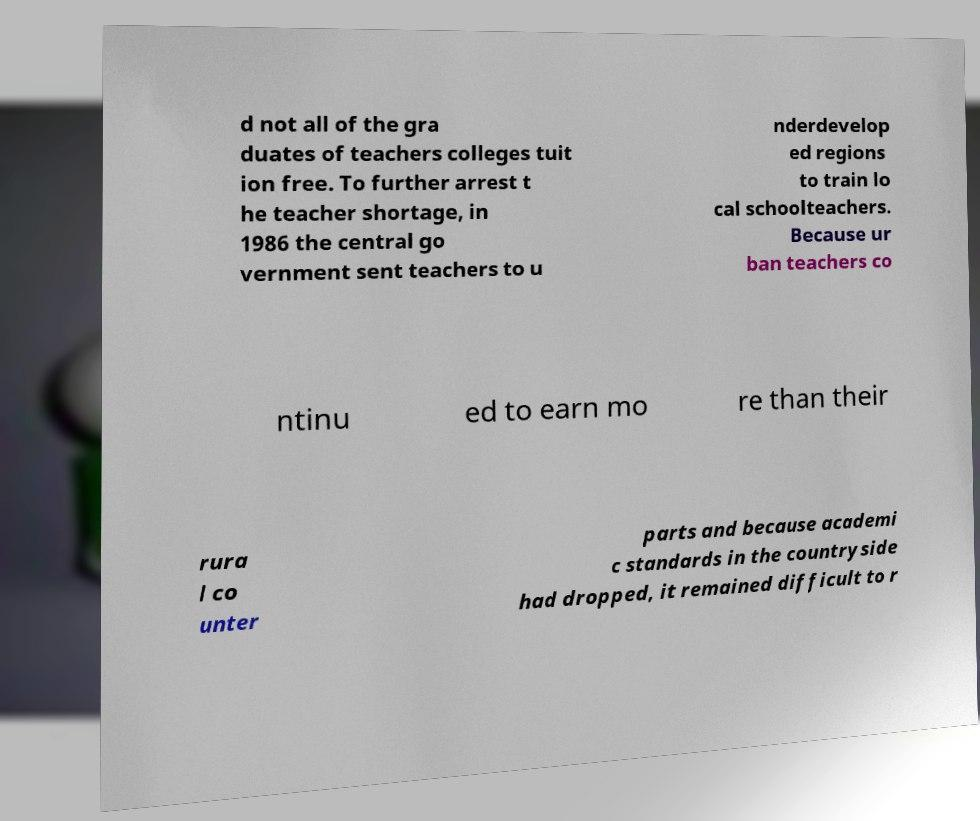Please read and relay the text visible in this image. What does it say? d not all of the gra duates of teachers colleges tuit ion free. To further arrest t he teacher shortage, in 1986 the central go vernment sent teachers to u nderdevelop ed regions to train lo cal schoolteachers. Because ur ban teachers co ntinu ed to earn mo re than their rura l co unter parts and because academi c standards in the countryside had dropped, it remained difficult to r 